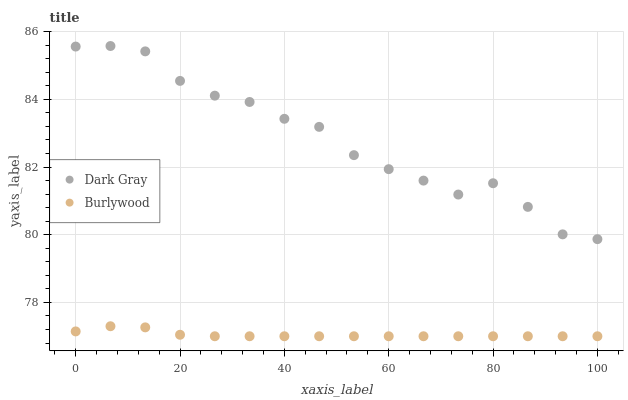Does Burlywood have the minimum area under the curve?
Answer yes or no. Yes. Does Dark Gray have the maximum area under the curve?
Answer yes or no. Yes. Does Burlywood have the maximum area under the curve?
Answer yes or no. No. Is Burlywood the smoothest?
Answer yes or no. Yes. Is Dark Gray the roughest?
Answer yes or no. Yes. Is Burlywood the roughest?
Answer yes or no. No. Does Burlywood have the lowest value?
Answer yes or no. Yes. Does Dark Gray have the highest value?
Answer yes or no. Yes. Does Burlywood have the highest value?
Answer yes or no. No. Is Burlywood less than Dark Gray?
Answer yes or no. Yes. Is Dark Gray greater than Burlywood?
Answer yes or no. Yes. Does Burlywood intersect Dark Gray?
Answer yes or no. No. 